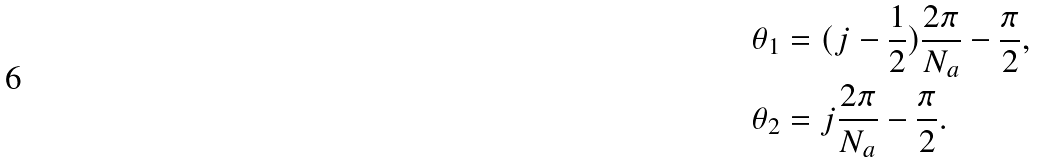<formula> <loc_0><loc_0><loc_500><loc_500>\theta _ { 1 } & = ( j - \frac { 1 } { 2 } ) \frac { 2 \pi } { N _ { a } } - \frac { \pi } { 2 } , \\ \theta _ { 2 } & = j \frac { 2 \pi } { N _ { a } } - \frac { \pi } { 2 } .</formula> 